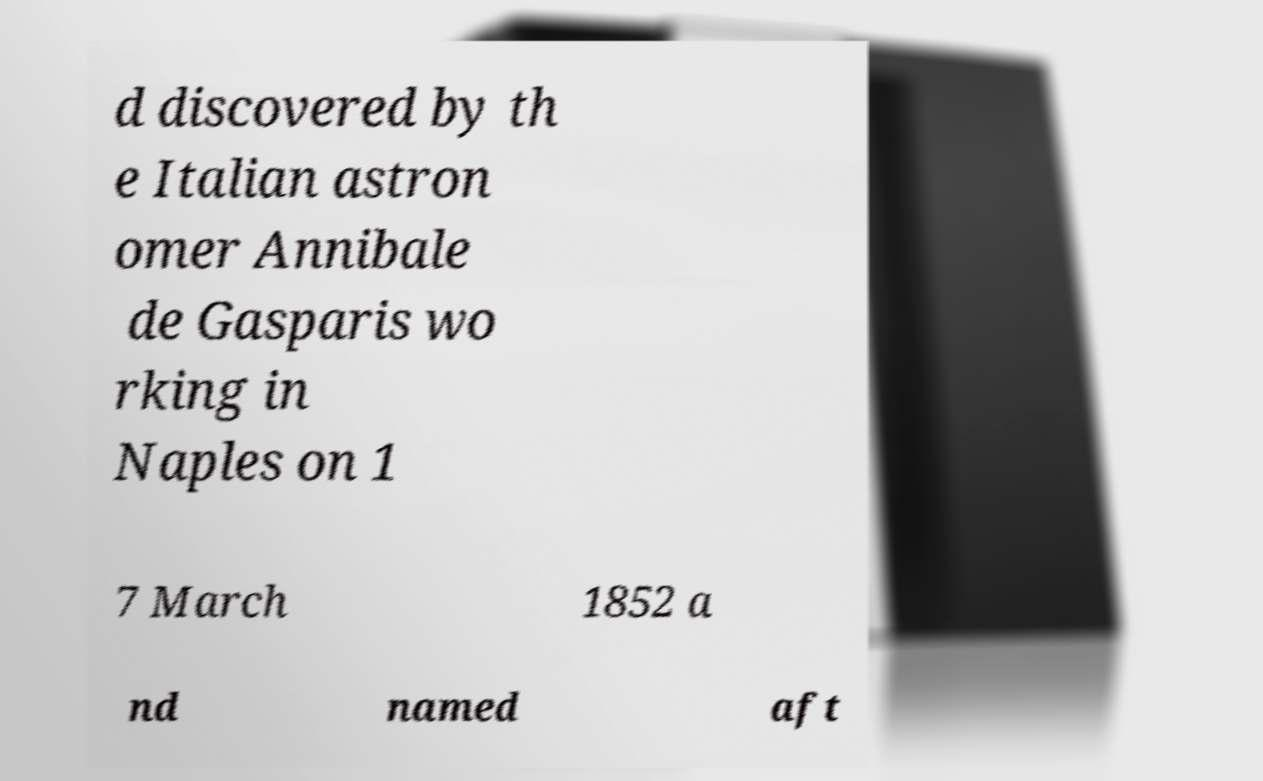There's text embedded in this image that I need extracted. Can you transcribe it verbatim? d discovered by th e Italian astron omer Annibale de Gasparis wo rking in Naples on 1 7 March 1852 a nd named aft 